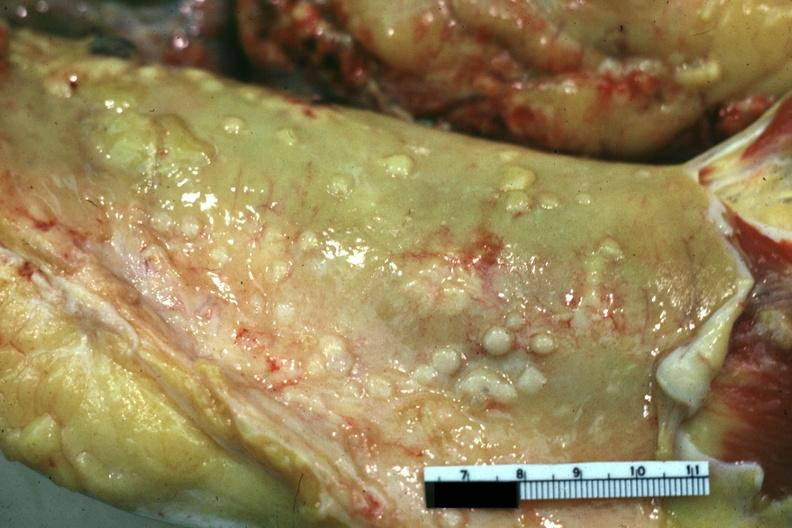what is present?
Answer the question using a single word or phrase. Abdomen 